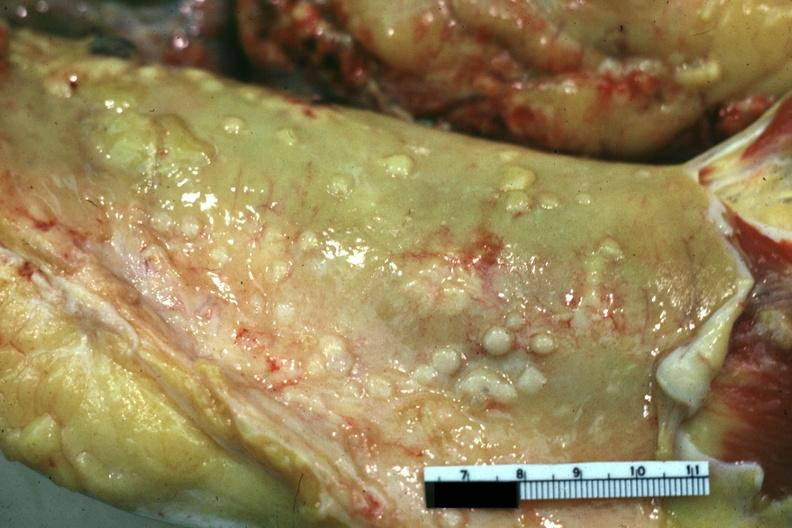what is present?
Answer the question using a single word or phrase. Abdomen 